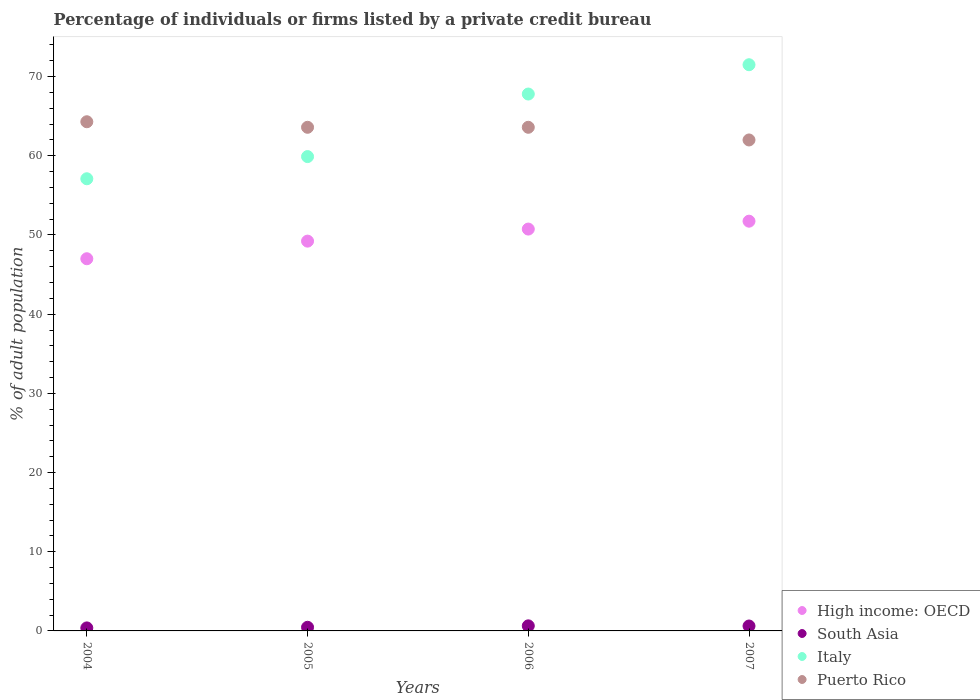What is the percentage of population listed by a private credit bureau in Puerto Rico in 2006?
Your response must be concise. 63.6. Across all years, what is the maximum percentage of population listed by a private credit bureau in South Asia?
Your response must be concise. 0.64. Across all years, what is the minimum percentage of population listed by a private credit bureau in Puerto Rico?
Provide a succinct answer. 62. In which year was the percentage of population listed by a private credit bureau in South Asia maximum?
Give a very brief answer. 2006. What is the total percentage of population listed by a private credit bureau in High income: OECD in the graph?
Provide a short and direct response. 198.71. What is the difference between the percentage of population listed by a private credit bureau in Italy in 2004 and that in 2005?
Offer a terse response. -2.8. What is the difference between the percentage of population listed by a private credit bureau in South Asia in 2004 and the percentage of population listed by a private credit bureau in Puerto Rico in 2005?
Ensure brevity in your answer.  -63.22. What is the average percentage of population listed by a private credit bureau in High income: OECD per year?
Keep it short and to the point. 49.68. In the year 2007, what is the difference between the percentage of population listed by a private credit bureau in South Asia and percentage of population listed by a private credit bureau in Italy?
Ensure brevity in your answer.  -70.88. In how many years, is the percentage of population listed by a private credit bureau in Puerto Rico greater than 44 %?
Give a very brief answer. 4. What is the ratio of the percentage of population listed by a private credit bureau in Puerto Rico in 2005 to that in 2007?
Offer a terse response. 1.03. Is the percentage of population listed by a private credit bureau in South Asia in 2005 less than that in 2006?
Your answer should be compact. Yes. What is the difference between the highest and the second highest percentage of population listed by a private credit bureau in High income: OECD?
Ensure brevity in your answer.  1. What is the difference between the highest and the lowest percentage of population listed by a private credit bureau in South Asia?
Offer a terse response. 0.26. In how many years, is the percentage of population listed by a private credit bureau in Italy greater than the average percentage of population listed by a private credit bureau in Italy taken over all years?
Offer a very short reply. 2. Is it the case that in every year, the sum of the percentage of population listed by a private credit bureau in Puerto Rico and percentage of population listed by a private credit bureau in Italy  is greater than the percentage of population listed by a private credit bureau in South Asia?
Offer a terse response. Yes. How many dotlines are there?
Offer a terse response. 4. Does the graph contain grids?
Keep it short and to the point. No. Where does the legend appear in the graph?
Provide a short and direct response. Bottom right. How many legend labels are there?
Make the answer very short. 4. What is the title of the graph?
Offer a terse response. Percentage of individuals or firms listed by a private credit bureau. What is the label or title of the Y-axis?
Your response must be concise. % of adult population. What is the % of adult population of High income: OECD in 2004?
Offer a terse response. 47. What is the % of adult population of South Asia in 2004?
Your response must be concise. 0.38. What is the % of adult population in Italy in 2004?
Your response must be concise. 57.1. What is the % of adult population of Puerto Rico in 2004?
Ensure brevity in your answer.  64.3. What is the % of adult population of High income: OECD in 2005?
Your response must be concise. 49.22. What is the % of adult population in South Asia in 2005?
Offer a very short reply. 0.46. What is the % of adult population of Italy in 2005?
Provide a short and direct response. 59.9. What is the % of adult population in Puerto Rico in 2005?
Keep it short and to the point. 63.6. What is the % of adult population in High income: OECD in 2006?
Your answer should be compact. 50.75. What is the % of adult population in South Asia in 2006?
Your response must be concise. 0.64. What is the % of adult population in Italy in 2006?
Provide a succinct answer. 67.8. What is the % of adult population in Puerto Rico in 2006?
Provide a succinct answer. 63.6. What is the % of adult population in High income: OECD in 2007?
Offer a very short reply. 51.74. What is the % of adult population in South Asia in 2007?
Offer a terse response. 0.62. What is the % of adult population of Italy in 2007?
Provide a short and direct response. 71.5. What is the % of adult population of Puerto Rico in 2007?
Ensure brevity in your answer.  62. Across all years, what is the maximum % of adult population in High income: OECD?
Your response must be concise. 51.74. Across all years, what is the maximum % of adult population of South Asia?
Provide a short and direct response. 0.64. Across all years, what is the maximum % of adult population in Italy?
Your response must be concise. 71.5. Across all years, what is the maximum % of adult population of Puerto Rico?
Your answer should be very brief. 64.3. Across all years, what is the minimum % of adult population in High income: OECD?
Provide a short and direct response. 47. Across all years, what is the minimum % of adult population of South Asia?
Give a very brief answer. 0.38. Across all years, what is the minimum % of adult population in Italy?
Ensure brevity in your answer.  57.1. What is the total % of adult population in High income: OECD in the graph?
Make the answer very short. 198.71. What is the total % of adult population in Italy in the graph?
Provide a succinct answer. 256.3. What is the total % of adult population of Puerto Rico in the graph?
Keep it short and to the point. 253.5. What is the difference between the % of adult population of High income: OECD in 2004 and that in 2005?
Offer a very short reply. -2.22. What is the difference between the % of adult population in South Asia in 2004 and that in 2005?
Keep it short and to the point. -0.08. What is the difference between the % of adult population of Italy in 2004 and that in 2005?
Ensure brevity in your answer.  -2.8. What is the difference between the % of adult population in High income: OECD in 2004 and that in 2006?
Offer a very short reply. -3.75. What is the difference between the % of adult population in South Asia in 2004 and that in 2006?
Provide a succinct answer. -0.26. What is the difference between the % of adult population in Italy in 2004 and that in 2006?
Give a very brief answer. -10.7. What is the difference between the % of adult population of Puerto Rico in 2004 and that in 2006?
Ensure brevity in your answer.  0.7. What is the difference between the % of adult population in High income: OECD in 2004 and that in 2007?
Ensure brevity in your answer.  -4.74. What is the difference between the % of adult population of South Asia in 2004 and that in 2007?
Your response must be concise. -0.24. What is the difference between the % of adult population in Italy in 2004 and that in 2007?
Ensure brevity in your answer.  -14.4. What is the difference between the % of adult population in High income: OECD in 2005 and that in 2006?
Ensure brevity in your answer.  -1.52. What is the difference between the % of adult population in South Asia in 2005 and that in 2006?
Your response must be concise. -0.18. What is the difference between the % of adult population in Italy in 2005 and that in 2006?
Make the answer very short. -7.9. What is the difference between the % of adult population in Puerto Rico in 2005 and that in 2006?
Make the answer very short. 0. What is the difference between the % of adult population in High income: OECD in 2005 and that in 2007?
Provide a short and direct response. -2.52. What is the difference between the % of adult population of South Asia in 2005 and that in 2007?
Offer a terse response. -0.16. What is the difference between the % of adult population of Puerto Rico in 2005 and that in 2007?
Your answer should be very brief. 1.6. What is the difference between the % of adult population in High income: OECD in 2006 and that in 2007?
Make the answer very short. -1. What is the difference between the % of adult population in Italy in 2006 and that in 2007?
Provide a short and direct response. -3.7. What is the difference between the % of adult population of Puerto Rico in 2006 and that in 2007?
Ensure brevity in your answer.  1.6. What is the difference between the % of adult population of High income: OECD in 2004 and the % of adult population of South Asia in 2005?
Ensure brevity in your answer.  46.54. What is the difference between the % of adult population in High income: OECD in 2004 and the % of adult population in Italy in 2005?
Give a very brief answer. -12.9. What is the difference between the % of adult population of High income: OECD in 2004 and the % of adult population of Puerto Rico in 2005?
Provide a succinct answer. -16.6. What is the difference between the % of adult population of South Asia in 2004 and the % of adult population of Italy in 2005?
Your response must be concise. -59.52. What is the difference between the % of adult population in South Asia in 2004 and the % of adult population in Puerto Rico in 2005?
Make the answer very short. -63.22. What is the difference between the % of adult population in High income: OECD in 2004 and the % of adult population in South Asia in 2006?
Your response must be concise. 46.36. What is the difference between the % of adult population in High income: OECD in 2004 and the % of adult population in Italy in 2006?
Ensure brevity in your answer.  -20.8. What is the difference between the % of adult population of High income: OECD in 2004 and the % of adult population of Puerto Rico in 2006?
Offer a very short reply. -16.6. What is the difference between the % of adult population in South Asia in 2004 and the % of adult population in Italy in 2006?
Ensure brevity in your answer.  -67.42. What is the difference between the % of adult population in South Asia in 2004 and the % of adult population in Puerto Rico in 2006?
Offer a terse response. -63.22. What is the difference between the % of adult population in Italy in 2004 and the % of adult population in Puerto Rico in 2006?
Provide a succinct answer. -6.5. What is the difference between the % of adult population of High income: OECD in 2004 and the % of adult population of South Asia in 2007?
Keep it short and to the point. 46.38. What is the difference between the % of adult population of High income: OECD in 2004 and the % of adult population of Italy in 2007?
Provide a succinct answer. -24.5. What is the difference between the % of adult population of High income: OECD in 2004 and the % of adult population of Puerto Rico in 2007?
Your answer should be compact. -15. What is the difference between the % of adult population of South Asia in 2004 and the % of adult population of Italy in 2007?
Keep it short and to the point. -71.12. What is the difference between the % of adult population of South Asia in 2004 and the % of adult population of Puerto Rico in 2007?
Provide a succinct answer. -61.62. What is the difference between the % of adult population of High income: OECD in 2005 and the % of adult population of South Asia in 2006?
Offer a very short reply. 48.58. What is the difference between the % of adult population of High income: OECD in 2005 and the % of adult population of Italy in 2006?
Give a very brief answer. -18.58. What is the difference between the % of adult population in High income: OECD in 2005 and the % of adult population in Puerto Rico in 2006?
Keep it short and to the point. -14.38. What is the difference between the % of adult population in South Asia in 2005 and the % of adult population in Italy in 2006?
Ensure brevity in your answer.  -67.34. What is the difference between the % of adult population of South Asia in 2005 and the % of adult population of Puerto Rico in 2006?
Your answer should be compact. -63.14. What is the difference between the % of adult population of High income: OECD in 2005 and the % of adult population of South Asia in 2007?
Give a very brief answer. 48.6. What is the difference between the % of adult population in High income: OECD in 2005 and the % of adult population in Italy in 2007?
Make the answer very short. -22.28. What is the difference between the % of adult population in High income: OECD in 2005 and the % of adult population in Puerto Rico in 2007?
Provide a succinct answer. -12.78. What is the difference between the % of adult population of South Asia in 2005 and the % of adult population of Italy in 2007?
Offer a very short reply. -71.04. What is the difference between the % of adult population of South Asia in 2005 and the % of adult population of Puerto Rico in 2007?
Ensure brevity in your answer.  -61.54. What is the difference between the % of adult population of High income: OECD in 2006 and the % of adult population of South Asia in 2007?
Ensure brevity in your answer.  50.13. What is the difference between the % of adult population in High income: OECD in 2006 and the % of adult population in Italy in 2007?
Give a very brief answer. -20.75. What is the difference between the % of adult population in High income: OECD in 2006 and the % of adult population in Puerto Rico in 2007?
Offer a terse response. -11.25. What is the difference between the % of adult population in South Asia in 2006 and the % of adult population in Italy in 2007?
Keep it short and to the point. -70.86. What is the difference between the % of adult population of South Asia in 2006 and the % of adult population of Puerto Rico in 2007?
Offer a very short reply. -61.36. What is the difference between the % of adult population of Italy in 2006 and the % of adult population of Puerto Rico in 2007?
Provide a succinct answer. 5.8. What is the average % of adult population of High income: OECD per year?
Provide a short and direct response. 49.68. What is the average % of adult population in South Asia per year?
Keep it short and to the point. 0.53. What is the average % of adult population in Italy per year?
Offer a terse response. 64.08. What is the average % of adult population of Puerto Rico per year?
Offer a terse response. 63.38. In the year 2004, what is the difference between the % of adult population in High income: OECD and % of adult population in South Asia?
Ensure brevity in your answer.  46.62. In the year 2004, what is the difference between the % of adult population of High income: OECD and % of adult population of Italy?
Provide a short and direct response. -10.1. In the year 2004, what is the difference between the % of adult population in High income: OECD and % of adult population in Puerto Rico?
Offer a terse response. -17.3. In the year 2004, what is the difference between the % of adult population in South Asia and % of adult population in Italy?
Keep it short and to the point. -56.72. In the year 2004, what is the difference between the % of adult population of South Asia and % of adult population of Puerto Rico?
Keep it short and to the point. -63.92. In the year 2005, what is the difference between the % of adult population in High income: OECD and % of adult population in South Asia?
Provide a short and direct response. 48.76. In the year 2005, what is the difference between the % of adult population in High income: OECD and % of adult population in Italy?
Your answer should be very brief. -10.68. In the year 2005, what is the difference between the % of adult population of High income: OECD and % of adult population of Puerto Rico?
Your answer should be compact. -14.38. In the year 2005, what is the difference between the % of adult population in South Asia and % of adult population in Italy?
Ensure brevity in your answer.  -59.44. In the year 2005, what is the difference between the % of adult population of South Asia and % of adult population of Puerto Rico?
Offer a terse response. -63.14. In the year 2006, what is the difference between the % of adult population of High income: OECD and % of adult population of South Asia?
Make the answer very short. 50.11. In the year 2006, what is the difference between the % of adult population of High income: OECD and % of adult population of Italy?
Your answer should be very brief. -17.05. In the year 2006, what is the difference between the % of adult population of High income: OECD and % of adult population of Puerto Rico?
Give a very brief answer. -12.85. In the year 2006, what is the difference between the % of adult population of South Asia and % of adult population of Italy?
Keep it short and to the point. -67.16. In the year 2006, what is the difference between the % of adult population of South Asia and % of adult population of Puerto Rico?
Ensure brevity in your answer.  -62.96. In the year 2007, what is the difference between the % of adult population of High income: OECD and % of adult population of South Asia?
Offer a terse response. 51.12. In the year 2007, what is the difference between the % of adult population in High income: OECD and % of adult population in Italy?
Give a very brief answer. -19.76. In the year 2007, what is the difference between the % of adult population of High income: OECD and % of adult population of Puerto Rico?
Provide a short and direct response. -10.26. In the year 2007, what is the difference between the % of adult population of South Asia and % of adult population of Italy?
Ensure brevity in your answer.  -70.88. In the year 2007, what is the difference between the % of adult population in South Asia and % of adult population in Puerto Rico?
Make the answer very short. -61.38. What is the ratio of the % of adult population in High income: OECD in 2004 to that in 2005?
Make the answer very short. 0.95. What is the ratio of the % of adult population in South Asia in 2004 to that in 2005?
Offer a very short reply. 0.83. What is the ratio of the % of adult population in Italy in 2004 to that in 2005?
Ensure brevity in your answer.  0.95. What is the ratio of the % of adult population of High income: OECD in 2004 to that in 2006?
Provide a short and direct response. 0.93. What is the ratio of the % of adult population in South Asia in 2004 to that in 2006?
Provide a succinct answer. 0.59. What is the ratio of the % of adult population in Italy in 2004 to that in 2006?
Keep it short and to the point. 0.84. What is the ratio of the % of adult population in Puerto Rico in 2004 to that in 2006?
Provide a succinct answer. 1.01. What is the ratio of the % of adult population in High income: OECD in 2004 to that in 2007?
Provide a short and direct response. 0.91. What is the ratio of the % of adult population in South Asia in 2004 to that in 2007?
Provide a succinct answer. 0.61. What is the ratio of the % of adult population in Italy in 2004 to that in 2007?
Offer a terse response. 0.8. What is the ratio of the % of adult population of Puerto Rico in 2004 to that in 2007?
Ensure brevity in your answer.  1.04. What is the ratio of the % of adult population in High income: OECD in 2005 to that in 2006?
Provide a succinct answer. 0.97. What is the ratio of the % of adult population in South Asia in 2005 to that in 2006?
Your answer should be compact. 0.72. What is the ratio of the % of adult population in Italy in 2005 to that in 2006?
Your answer should be compact. 0.88. What is the ratio of the % of adult population of Puerto Rico in 2005 to that in 2006?
Your answer should be very brief. 1. What is the ratio of the % of adult population of High income: OECD in 2005 to that in 2007?
Make the answer very short. 0.95. What is the ratio of the % of adult population in South Asia in 2005 to that in 2007?
Make the answer very short. 0.74. What is the ratio of the % of adult population in Italy in 2005 to that in 2007?
Provide a short and direct response. 0.84. What is the ratio of the % of adult population in Puerto Rico in 2005 to that in 2007?
Offer a terse response. 1.03. What is the ratio of the % of adult population of High income: OECD in 2006 to that in 2007?
Your response must be concise. 0.98. What is the ratio of the % of adult population in South Asia in 2006 to that in 2007?
Provide a short and direct response. 1.03. What is the ratio of the % of adult population in Italy in 2006 to that in 2007?
Your answer should be very brief. 0.95. What is the ratio of the % of adult population of Puerto Rico in 2006 to that in 2007?
Give a very brief answer. 1.03. What is the difference between the highest and the second highest % of adult population in High income: OECD?
Your answer should be very brief. 1. What is the difference between the highest and the second highest % of adult population of South Asia?
Your response must be concise. 0.02. What is the difference between the highest and the second highest % of adult population of Italy?
Give a very brief answer. 3.7. What is the difference between the highest and the lowest % of adult population in High income: OECD?
Give a very brief answer. 4.74. What is the difference between the highest and the lowest % of adult population in South Asia?
Your answer should be compact. 0.26. 